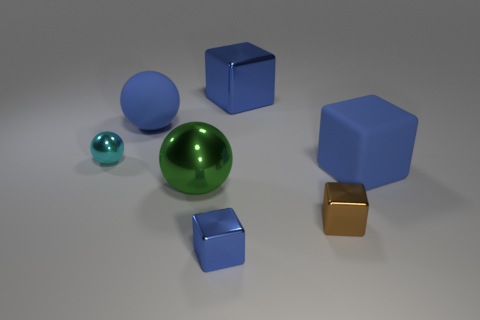Subtract all blue cubes. How many were subtracted if there are1blue cubes left? 2 Subtract all purple cylinders. How many blue cubes are left? 3 Add 3 large blue shiny blocks. How many objects exist? 10 Subtract all cubes. How many objects are left? 3 Add 2 large yellow cylinders. How many large yellow cylinders exist? 2 Subtract 0 cyan cylinders. How many objects are left? 7 Subtract all big balls. Subtract all cyan metallic balls. How many objects are left? 4 Add 2 tiny blue things. How many tiny blue things are left? 3 